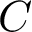Convert formula to latex. <formula><loc_0><loc_0><loc_500><loc_500>C</formula> 